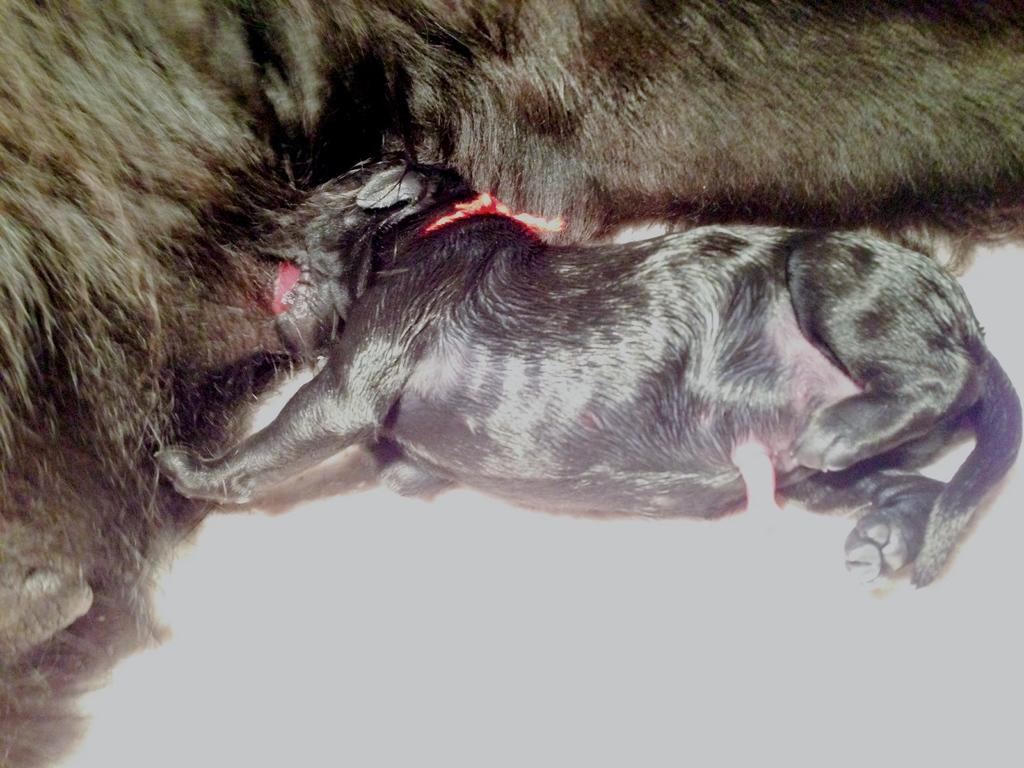How many animals are present in the image? There are two animals in the image. Is there a pig in the library in the image? There is no information about a pig or a library in the image, so we cannot answer that question. 